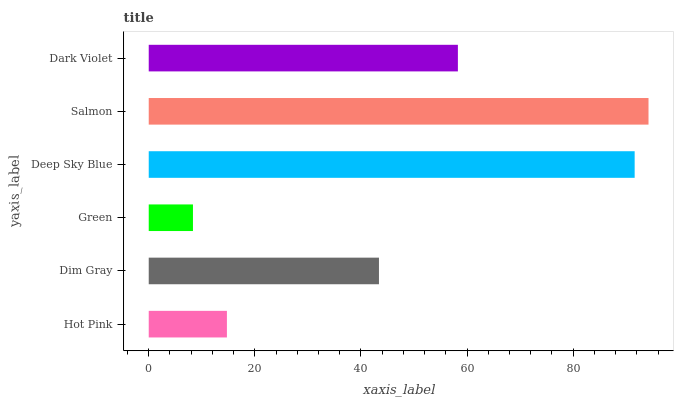Is Green the minimum?
Answer yes or no. Yes. Is Salmon the maximum?
Answer yes or no. Yes. Is Dim Gray the minimum?
Answer yes or no. No. Is Dim Gray the maximum?
Answer yes or no. No. Is Dim Gray greater than Hot Pink?
Answer yes or no. Yes. Is Hot Pink less than Dim Gray?
Answer yes or no. Yes. Is Hot Pink greater than Dim Gray?
Answer yes or no. No. Is Dim Gray less than Hot Pink?
Answer yes or no. No. Is Dark Violet the high median?
Answer yes or no. Yes. Is Dim Gray the low median?
Answer yes or no. Yes. Is Green the high median?
Answer yes or no. No. Is Salmon the low median?
Answer yes or no. No. 